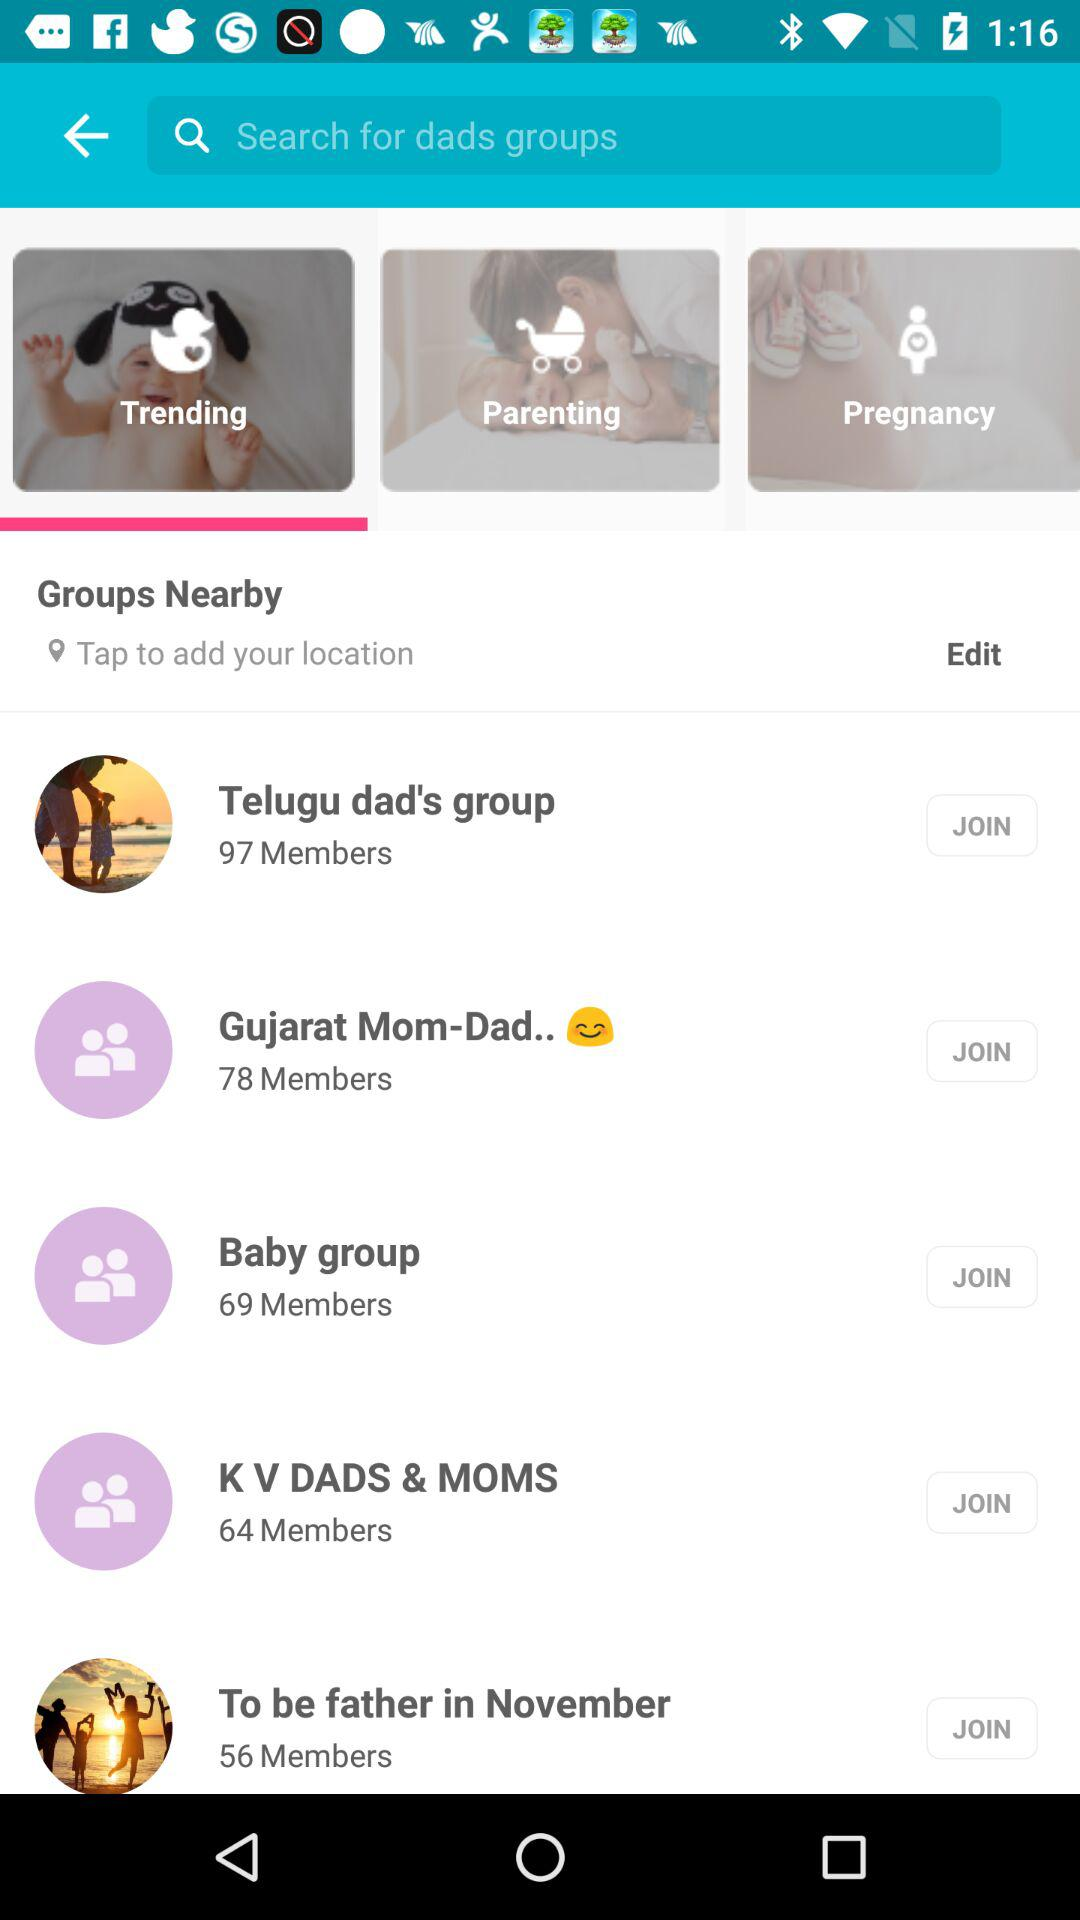What are the locations of the dad groups?
When the provided information is insufficient, respond with <no answer>. <no answer> 